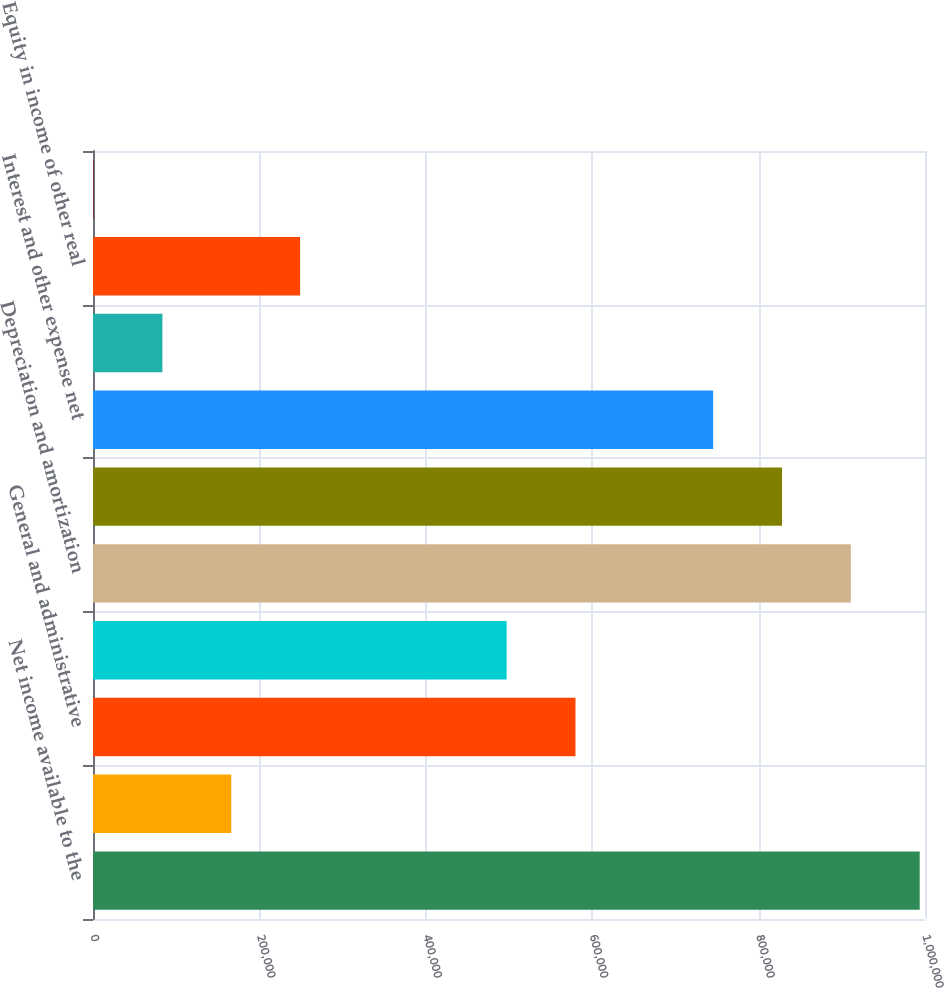Convert chart. <chart><loc_0><loc_0><loc_500><loc_500><bar_chart><fcel>Net income available to the<fcel>Management and other fee<fcel>General and administrative<fcel>Impairment charges<fcel>Depreciation and amortization<fcel>Gain on sale of operating<fcel>Interest and other expense net<fcel>Provision/(benefit) for income<fcel>Equity in income of other real<fcel>Net (loss)/income attributable<nl><fcel>993628<fcel>166161<fcel>579895<fcel>497148<fcel>910882<fcel>828135<fcel>745388<fcel>83414.7<fcel>248908<fcel>668<nl></chart> 